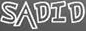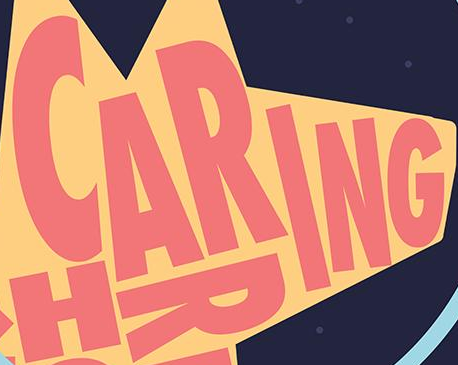What words are shown in these images in order, separated by a semicolon? SADID; CARING 